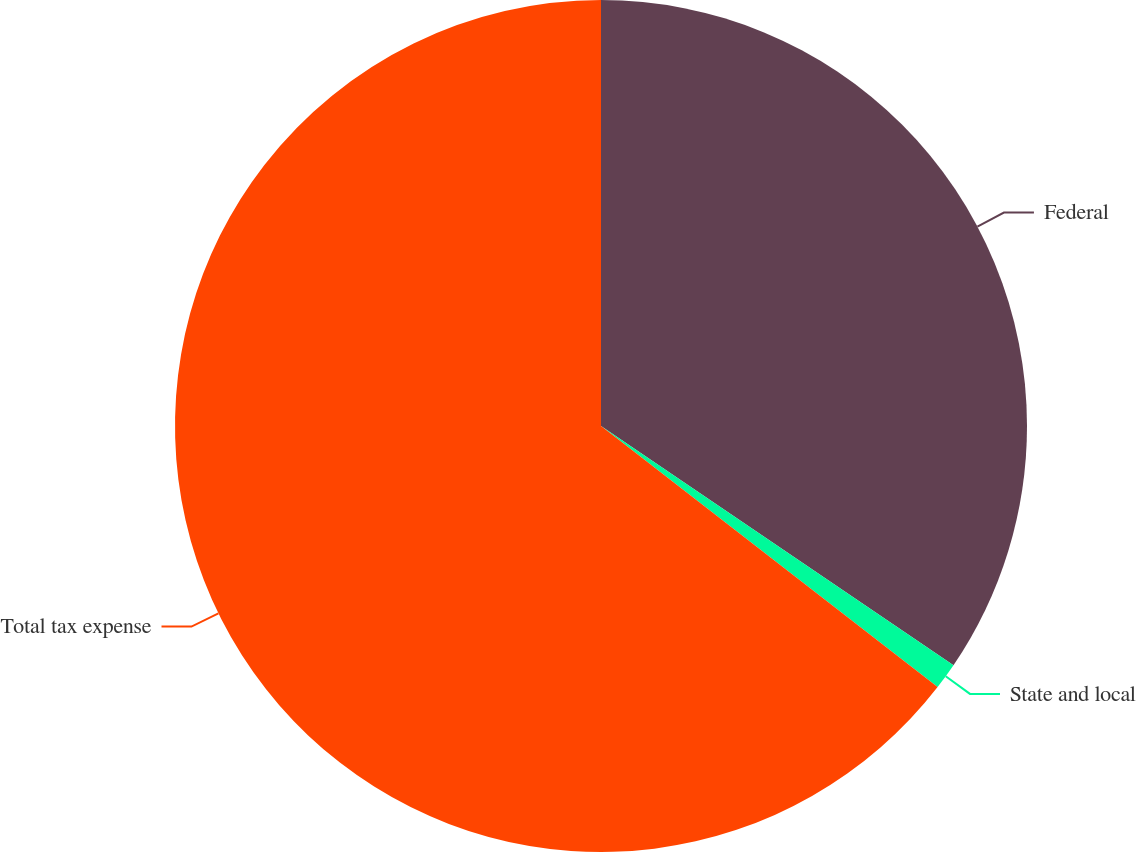Convert chart to OTSL. <chart><loc_0><loc_0><loc_500><loc_500><pie_chart><fcel>Federal<fcel>State and local<fcel>Total tax expense<nl><fcel>34.49%<fcel>1.01%<fcel>64.5%<nl></chart> 